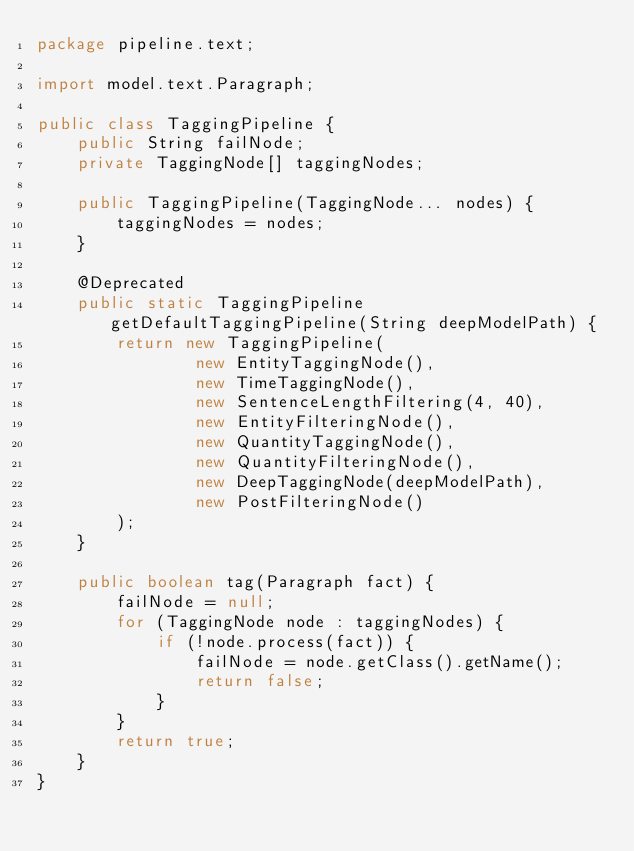<code> <loc_0><loc_0><loc_500><loc_500><_Java_>package pipeline.text;

import model.text.Paragraph;

public class TaggingPipeline {
    public String failNode;
    private TaggingNode[] taggingNodes;

    public TaggingPipeline(TaggingNode... nodes) {
        taggingNodes = nodes;
    }

    @Deprecated
    public static TaggingPipeline getDefaultTaggingPipeline(String deepModelPath) {
        return new TaggingPipeline(
                new EntityTaggingNode(),
                new TimeTaggingNode(),
                new SentenceLengthFiltering(4, 40),
                new EntityFilteringNode(),
                new QuantityTaggingNode(),
                new QuantityFilteringNode(),
                new DeepTaggingNode(deepModelPath),
                new PostFilteringNode()
        );
    }

    public boolean tag(Paragraph fact) {
        failNode = null;
        for (TaggingNode node : taggingNodes) {
            if (!node.process(fact)) {
                failNode = node.getClass().getName();
                return false;
            }
        }
        return true;
    }
}
</code> 